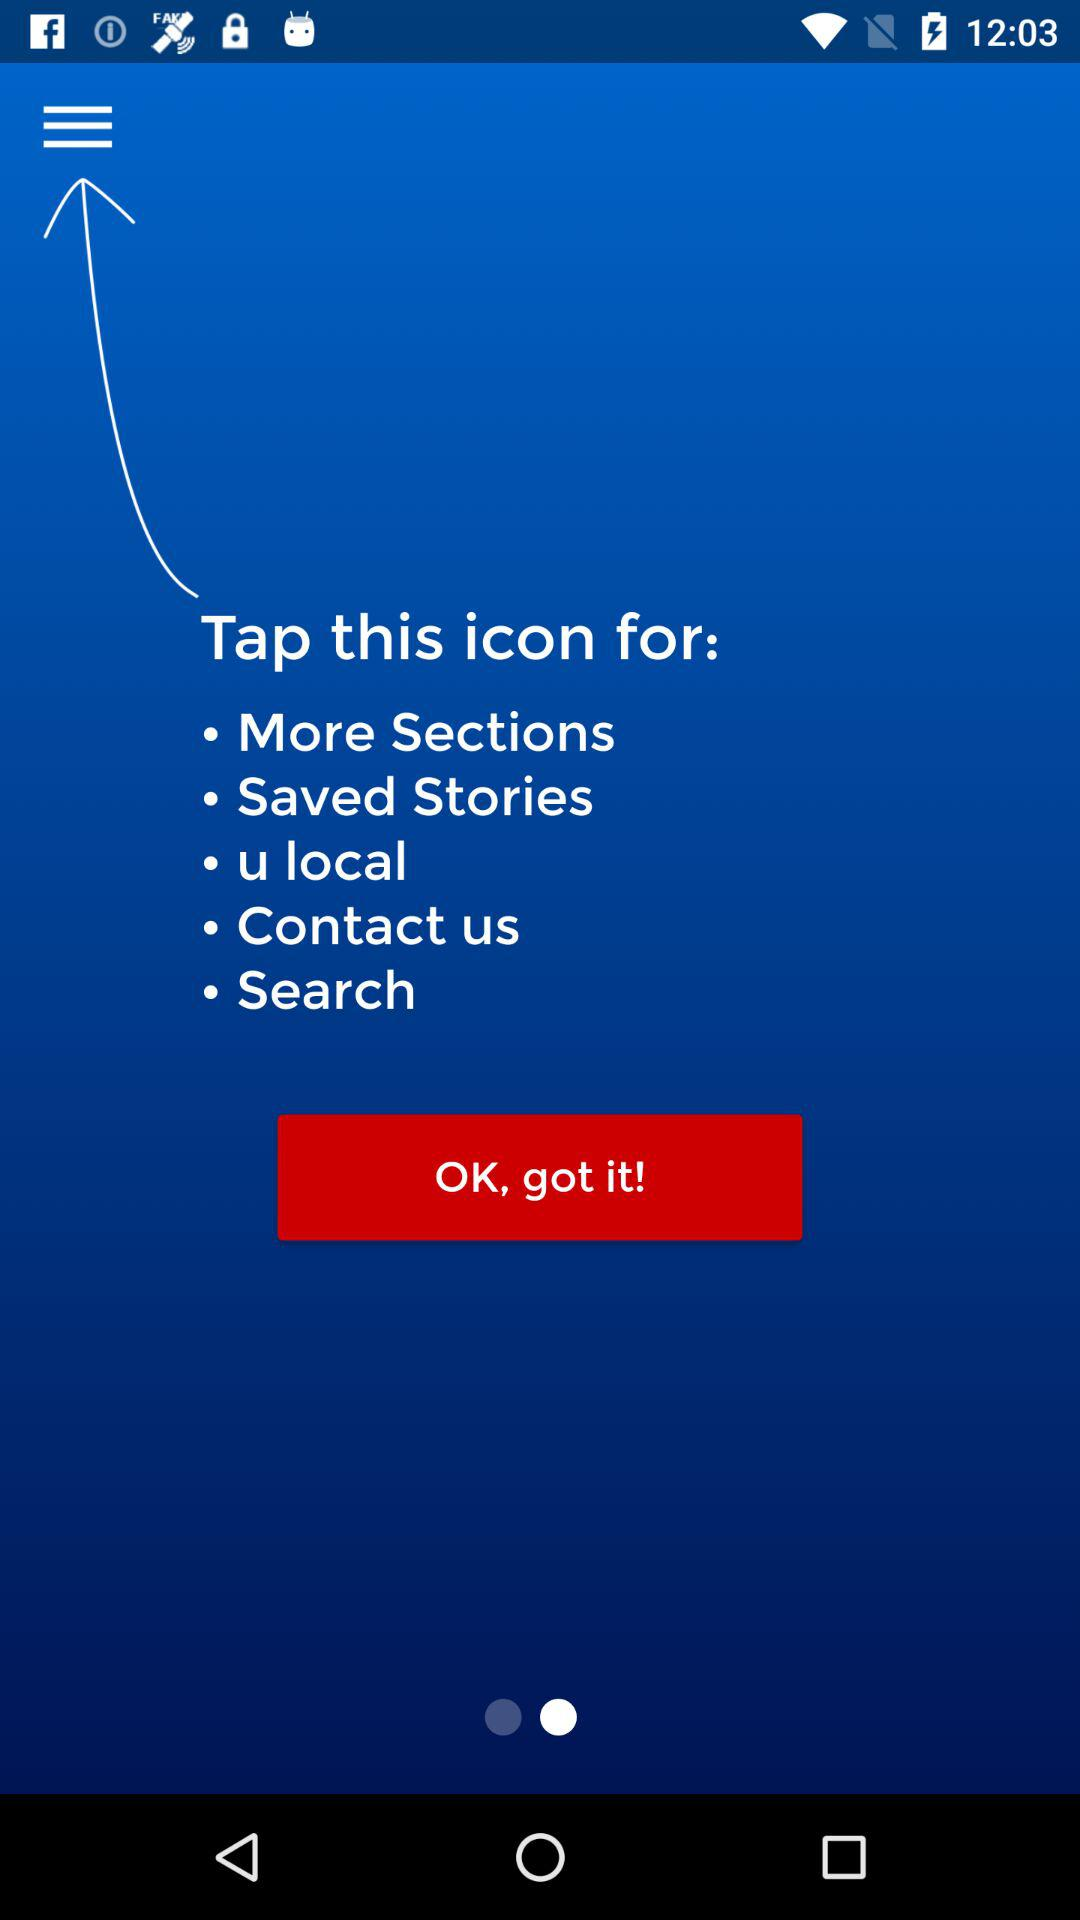How many sections are there in the menu?
Answer the question using a single word or phrase. 5 